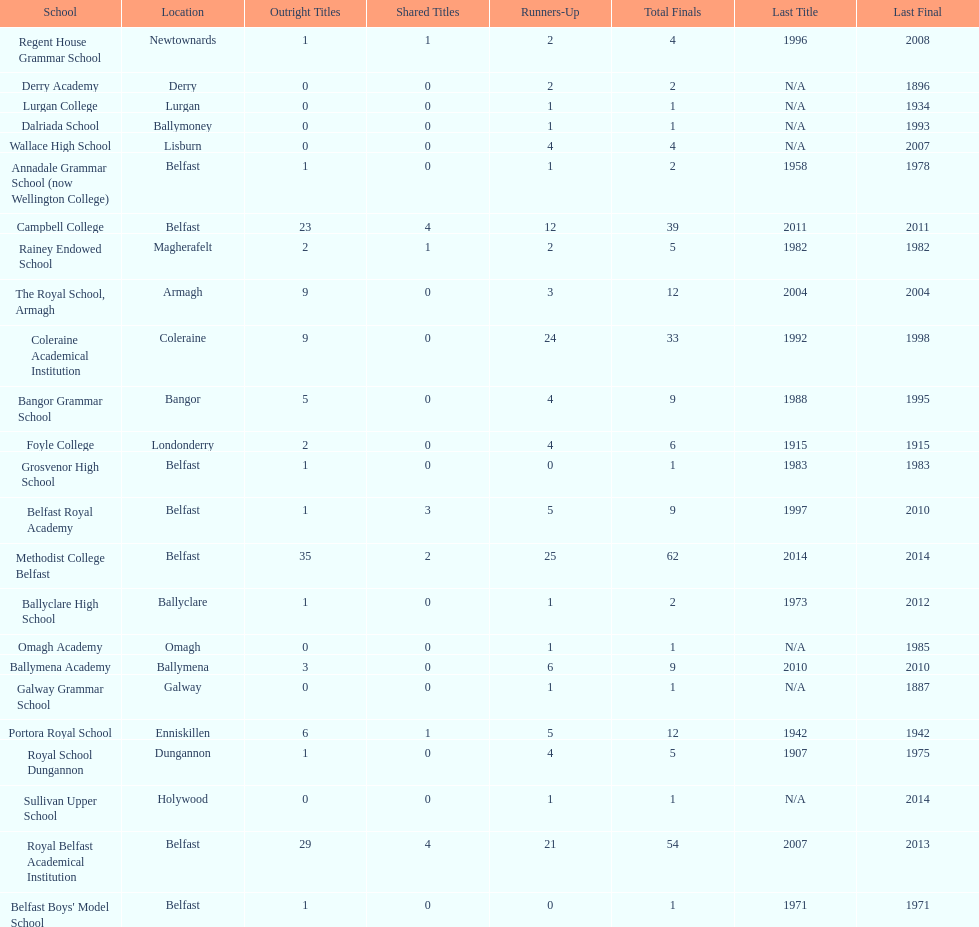What number of total finals does foyle college have? 6. 